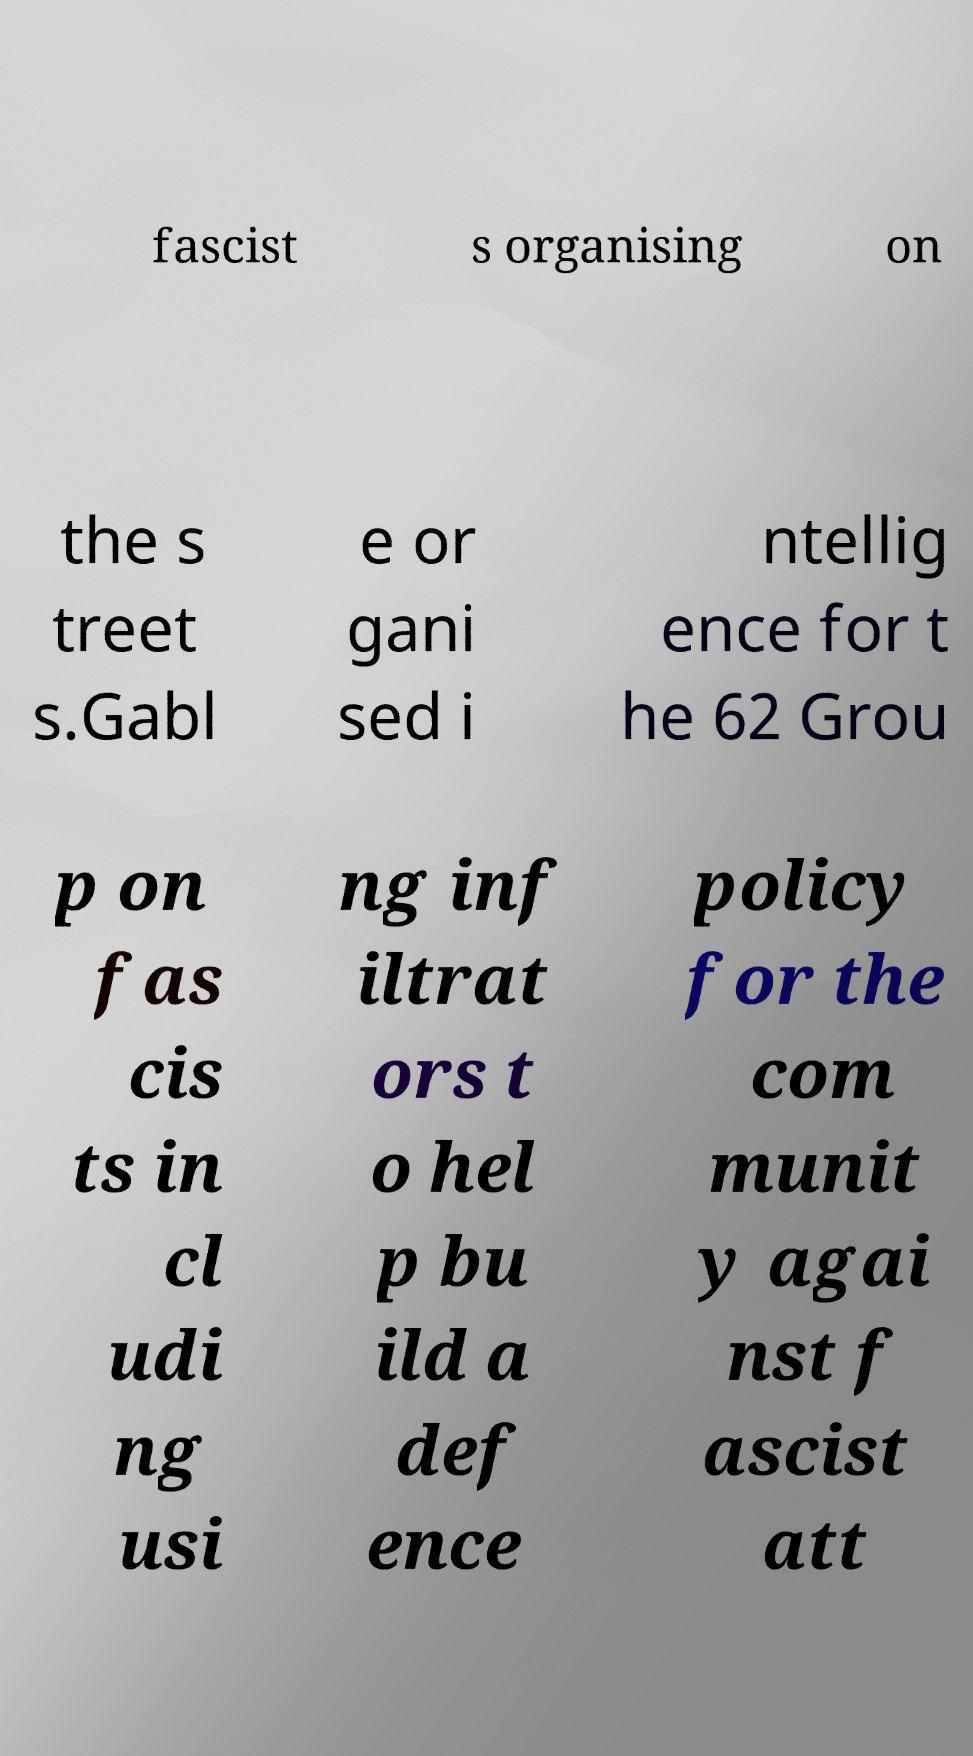I need the written content from this picture converted into text. Can you do that? fascist s organising on the s treet s.Gabl e or gani sed i ntellig ence for t he 62 Grou p on fas cis ts in cl udi ng usi ng inf iltrat ors t o hel p bu ild a def ence policy for the com munit y agai nst f ascist att 